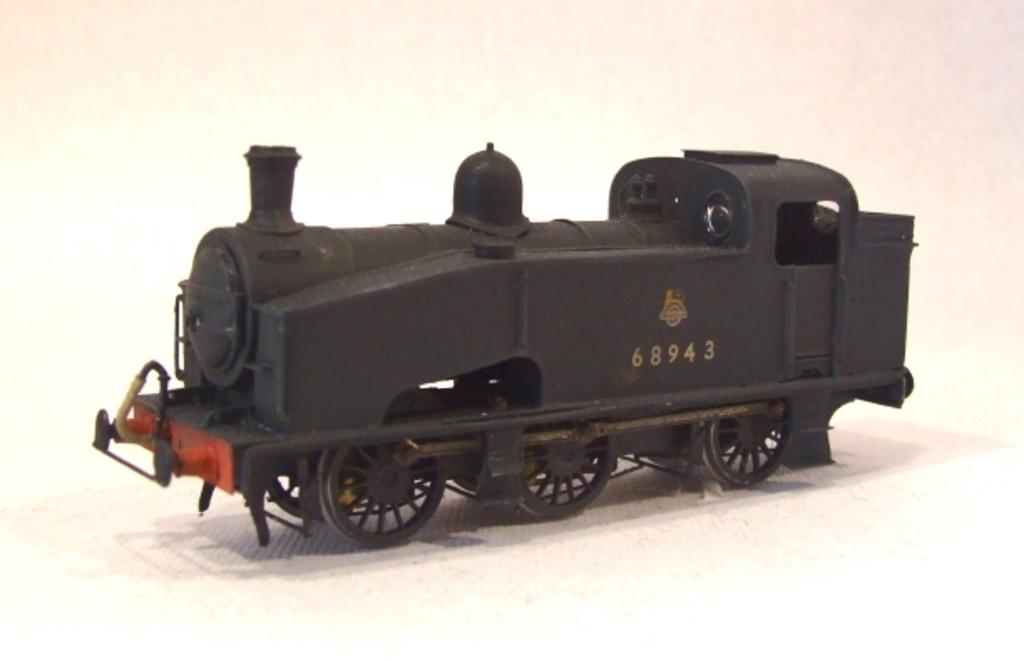What type of toy is present in the image? There is a toy steam engine in the image. What type of shop can be seen in the image? There is no shop present in the image; it features a toy steam engine. Can you tell me how many zebras are visible in the image? There are no zebras present in the image; it features a toy steam engine. 